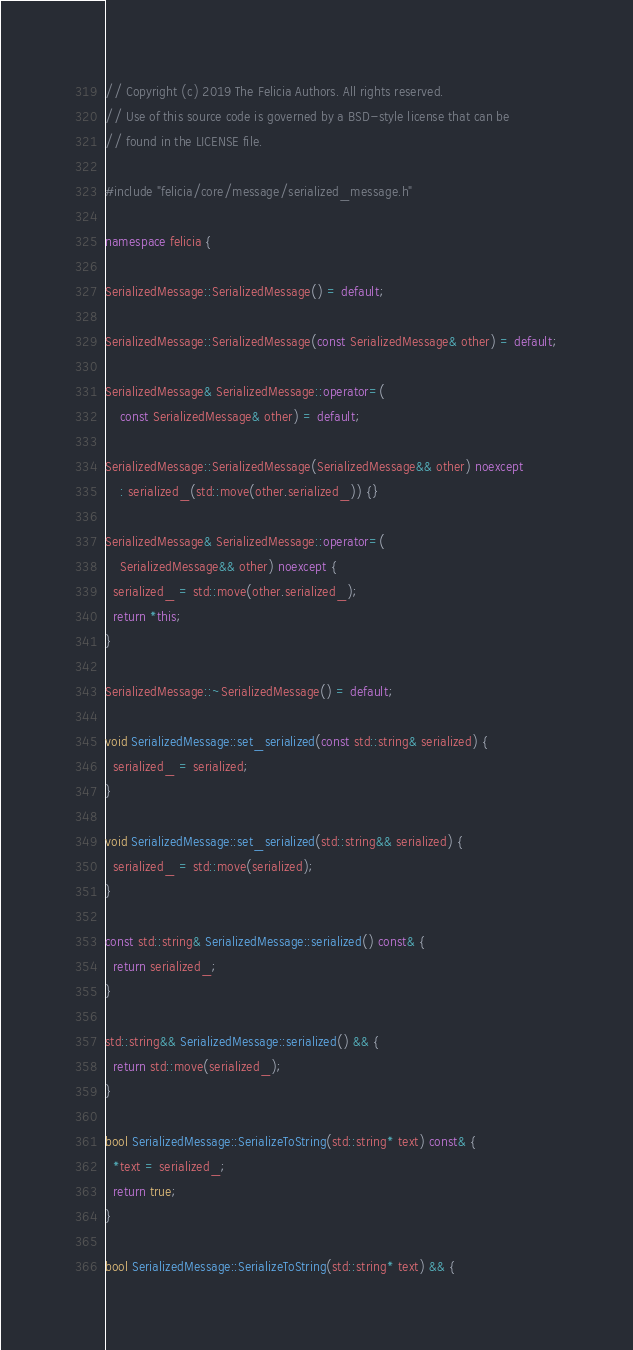<code> <loc_0><loc_0><loc_500><loc_500><_C++_>// Copyright (c) 2019 The Felicia Authors. All rights reserved.
// Use of this source code is governed by a BSD-style license that can be
// found in the LICENSE file.

#include "felicia/core/message/serialized_message.h"

namespace felicia {

SerializedMessage::SerializedMessage() = default;

SerializedMessage::SerializedMessage(const SerializedMessage& other) = default;

SerializedMessage& SerializedMessage::operator=(
    const SerializedMessage& other) = default;

SerializedMessage::SerializedMessage(SerializedMessage&& other) noexcept
    : serialized_(std::move(other.serialized_)) {}

SerializedMessage& SerializedMessage::operator=(
    SerializedMessage&& other) noexcept {
  serialized_ = std::move(other.serialized_);
  return *this;
}

SerializedMessage::~SerializedMessage() = default;

void SerializedMessage::set_serialized(const std::string& serialized) {
  serialized_ = serialized;
}

void SerializedMessage::set_serialized(std::string&& serialized) {
  serialized_ = std::move(serialized);
}

const std::string& SerializedMessage::serialized() const& {
  return serialized_;
}

std::string&& SerializedMessage::serialized() && {
  return std::move(serialized_);
}

bool SerializedMessage::SerializeToString(std::string* text) const& {
  *text = serialized_;
  return true;
}

bool SerializedMessage::SerializeToString(std::string* text) && {</code> 